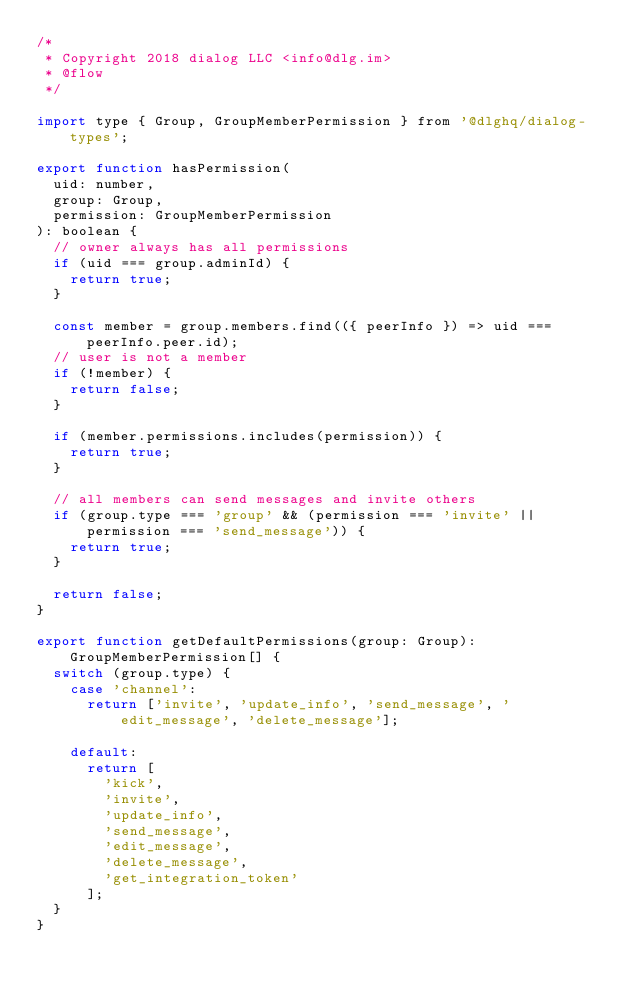Convert code to text. <code><loc_0><loc_0><loc_500><loc_500><_JavaScript_>/*
 * Copyright 2018 dialog LLC <info@dlg.im>
 * @flow
 */

import type { Group, GroupMemberPermission } from '@dlghq/dialog-types';

export function hasPermission(
  uid: number,
  group: Group,
  permission: GroupMemberPermission
): boolean {
  // owner always has all permissions
  if (uid === group.adminId) {
    return true;
  }

  const member = group.members.find(({ peerInfo }) => uid === peerInfo.peer.id);
  // user is not a member
  if (!member) {
    return false;
  }

  if (member.permissions.includes(permission)) {
    return true;
  }

  // all members can send messages and invite others
  if (group.type === 'group' && (permission === 'invite' || permission === 'send_message')) {
    return true;
  }

  return false;
}

export function getDefaultPermissions(group: Group): GroupMemberPermission[] {
  switch (group.type) {
    case 'channel':
      return ['invite', 'update_info', 'send_message', 'edit_message', 'delete_message'];

    default:
      return [
        'kick',
        'invite',
        'update_info',
        'send_message',
        'edit_message',
        'delete_message',
        'get_integration_token'
      ];
  }
}
</code> 